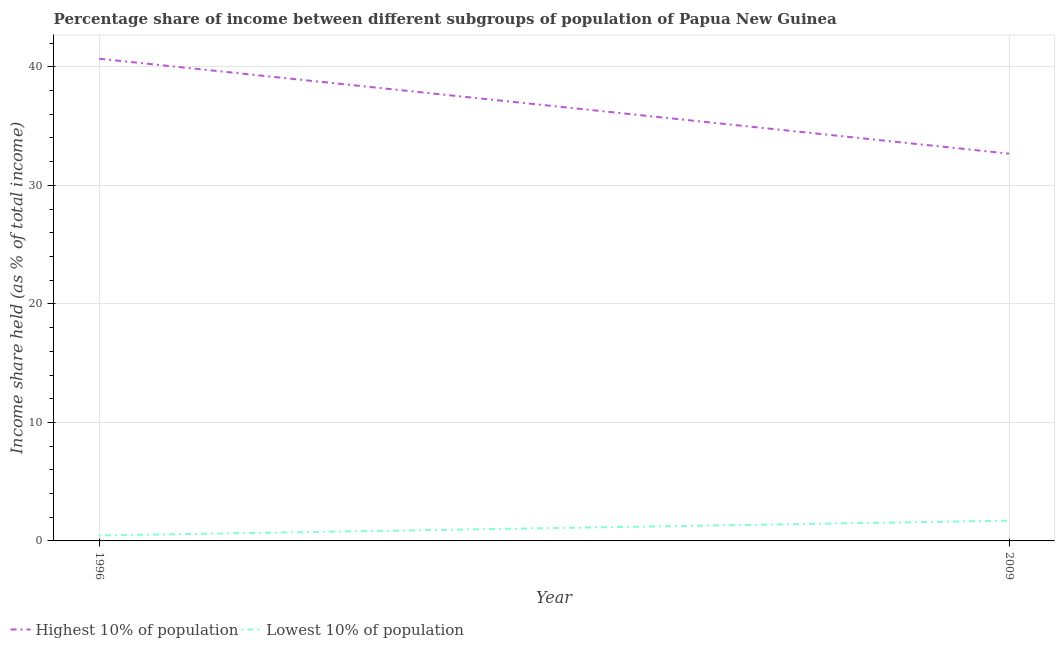Does the line corresponding to income share held by highest 10% of the population intersect with the line corresponding to income share held by lowest 10% of the population?
Your answer should be compact. No. Is the number of lines equal to the number of legend labels?
Ensure brevity in your answer.  Yes. What is the income share held by lowest 10% of the population in 2009?
Your answer should be compact. 1.71. Across all years, what is the maximum income share held by lowest 10% of the population?
Ensure brevity in your answer.  1.71. Across all years, what is the minimum income share held by lowest 10% of the population?
Ensure brevity in your answer.  0.46. In which year was the income share held by highest 10% of the population maximum?
Give a very brief answer. 1996. In which year was the income share held by lowest 10% of the population minimum?
Your answer should be very brief. 1996. What is the total income share held by highest 10% of the population in the graph?
Your response must be concise. 73.37. What is the difference between the income share held by lowest 10% of the population in 1996 and that in 2009?
Your answer should be very brief. -1.25. What is the difference between the income share held by lowest 10% of the population in 1996 and the income share held by highest 10% of the population in 2009?
Give a very brief answer. -32.22. What is the average income share held by highest 10% of the population per year?
Offer a very short reply. 36.69. In the year 1996, what is the difference between the income share held by highest 10% of the population and income share held by lowest 10% of the population?
Offer a very short reply. 40.23. In how many years, is the income share held by highest 10% of the population greater than 22 %?
Make the answer very short. 2. What is the ratio of the income share held by lowest 10% of the population in 1996 to that in 2009?
Your answer should be compact. 0.27. In how many years, is the income share held by lowest 10% of the population greater than the average income share held by lowest 10% of the population taken over all years?
Provide a succinct answer. 1. Does the income share held by highest 10% of the population monotonically increase over the years?
Your answer should be very brief. No. Is the income share held by lowest 10% of the population strictly greater than the income share held by highest 10% of the population over the years?
Keep it short and to the point. No. Is the income share held by highest 10% of the population strictly less than the income share held by lowest 10% of the population over the years?
Give a very brief answer. No. How many years are there in the graph?
Your response must be concise. 2. Are the values on the major ticks of Y-axis written in scientific E-notation?
Your answer should be very brief. No. Does the graph contain any zero values?
Provide a short and direct response. No. Where does the legend appear in the graph?
Ensure brevity in your answer.  Bottom left. How are the legend labels stacked?
Give a very brief answer. Horizontal. What is the title of the graph?
Provide a succinct answer. Percentage share of income between different subgroups of population of Papua New Guinea. What is the label or title of the Y-axis?
Offer a very short reply. Income share held (as % of total income). What is the Income share held (as % of total income) of Highest 10% of population in 1996?
Ensure brevity in your answer.  40.69. What is the Income share held (as % of total income) of Lowest 10% of population in 1996?
Offer a very short reply. 0.46. What is the Income share held (as % of total income) of Highest 10% of population in 2009?
Offer a very short reply. 32.68. What is the Income share held (as % of total income) of Lowest 10% of population in 2009?
Provide a succinct answer. 1.71. Across all years, what is the maximum Income share held (as % of total income) of Highest 10% of population?
Make the answer very short. 40.69. Across all years, what is the maximum Income share held (as % of total income) in Lowest 10% of population?
Make the answer very short. 1.71. Across all years, what is the minimum Income share held (as % of total income) of Highest 10% of population?
Offer a terse response. 32.68. Across all years, what is the minimum Income share held (as % of total income) of Lowest 10% of population?
Keep it short and to the point. 0.46. What is the total Income share held (as % of total income) of Highest 10% of population in the graph?
Your answer should be compact. 73.37. What is the total Income share held (as % of total income) in Lowest 10% of population in the graph?
Provide a short and direct response. 2.17. What is the difference between the Income share held (as % of total income) in Highest 10% of population in 1996 and that in 2009?
Ensure brevity in your answer.  8.01. What is the difference between the Income share held (as % of total income) in Lowest 10% of population in 1996 and that in 2009?
Keep it short and to the point. -1.25. What is the difference between the Income share held (as % of total income) in Highest 10% of population in 1996 and the Income share held (as % of total income) in Lowest 10% of population in 2009?
Ensure brevity in your answer.  38.98. What is the average Income share held (as % of total income) of Highest 10% of population per year?
Offer a very short reply. 36.69. What is the average Income share held (as % of total income) of Lowest 10% of population per year?
Your answer should be compact. 1.08. In the year 1996, what is the difference between the Income share held (as % of total income) of Highest 10% of population and Income share held (as % of total income) of Lowest 10% of population?
Offer a very short reply. 40.23. In the year 2009, what is the difference between the Income share held (as % of total income) in Highest 10% of population and Income share held (as % of total income) in Lowest 10% of population?
Your answer should be very brief. 30.97. What is the ratio of the Income share held (as % of total income) of Highest 10% of population in 1996 to that in 2009?
Your answer should be compact. 1.25. What is the ratio of the Income share held (as % of total income) in Lowest 10% of population in 1996 to that in 2009?
Give a very brief answer. 0.27. What is the difference between the highest and the second highest Income share held (as % of total income) in Highest 10% of population?
Give a very brief answer. 8.01. What is the difference between the highest and the lowest Income share held (as % of total income) in Highest 10% of population?
Offer a very short reply. 8.01. 